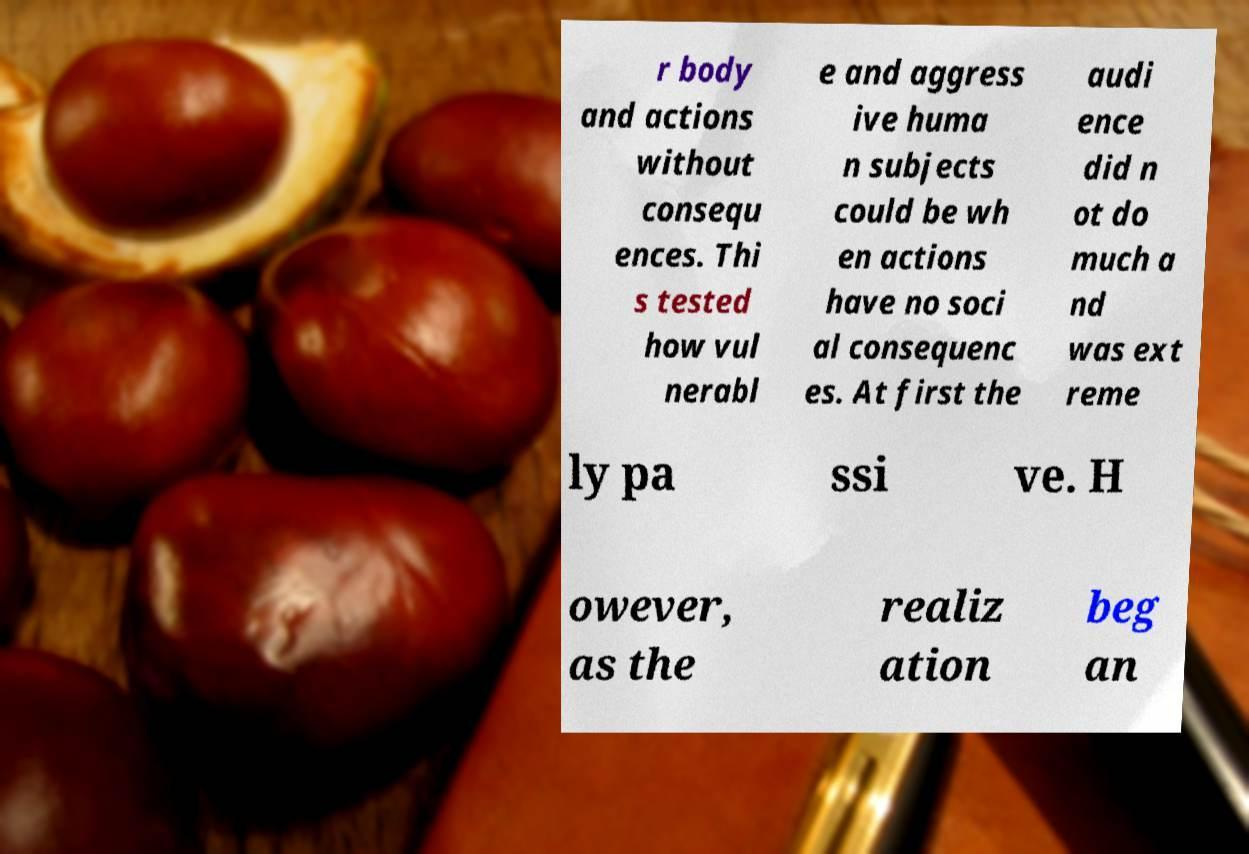For documentation purposes, I need the text within this image transcribed. Could you provide that? r body and actions without consequ ences. Thi s tested how vul nerabl e and aggress ive huma n subjects could be wh en actions have no soci al consequenc es. At first the audi ence did n ot do much a nd was ext reme ly pa ssi ve. H owever, as the realiz ation beg an 